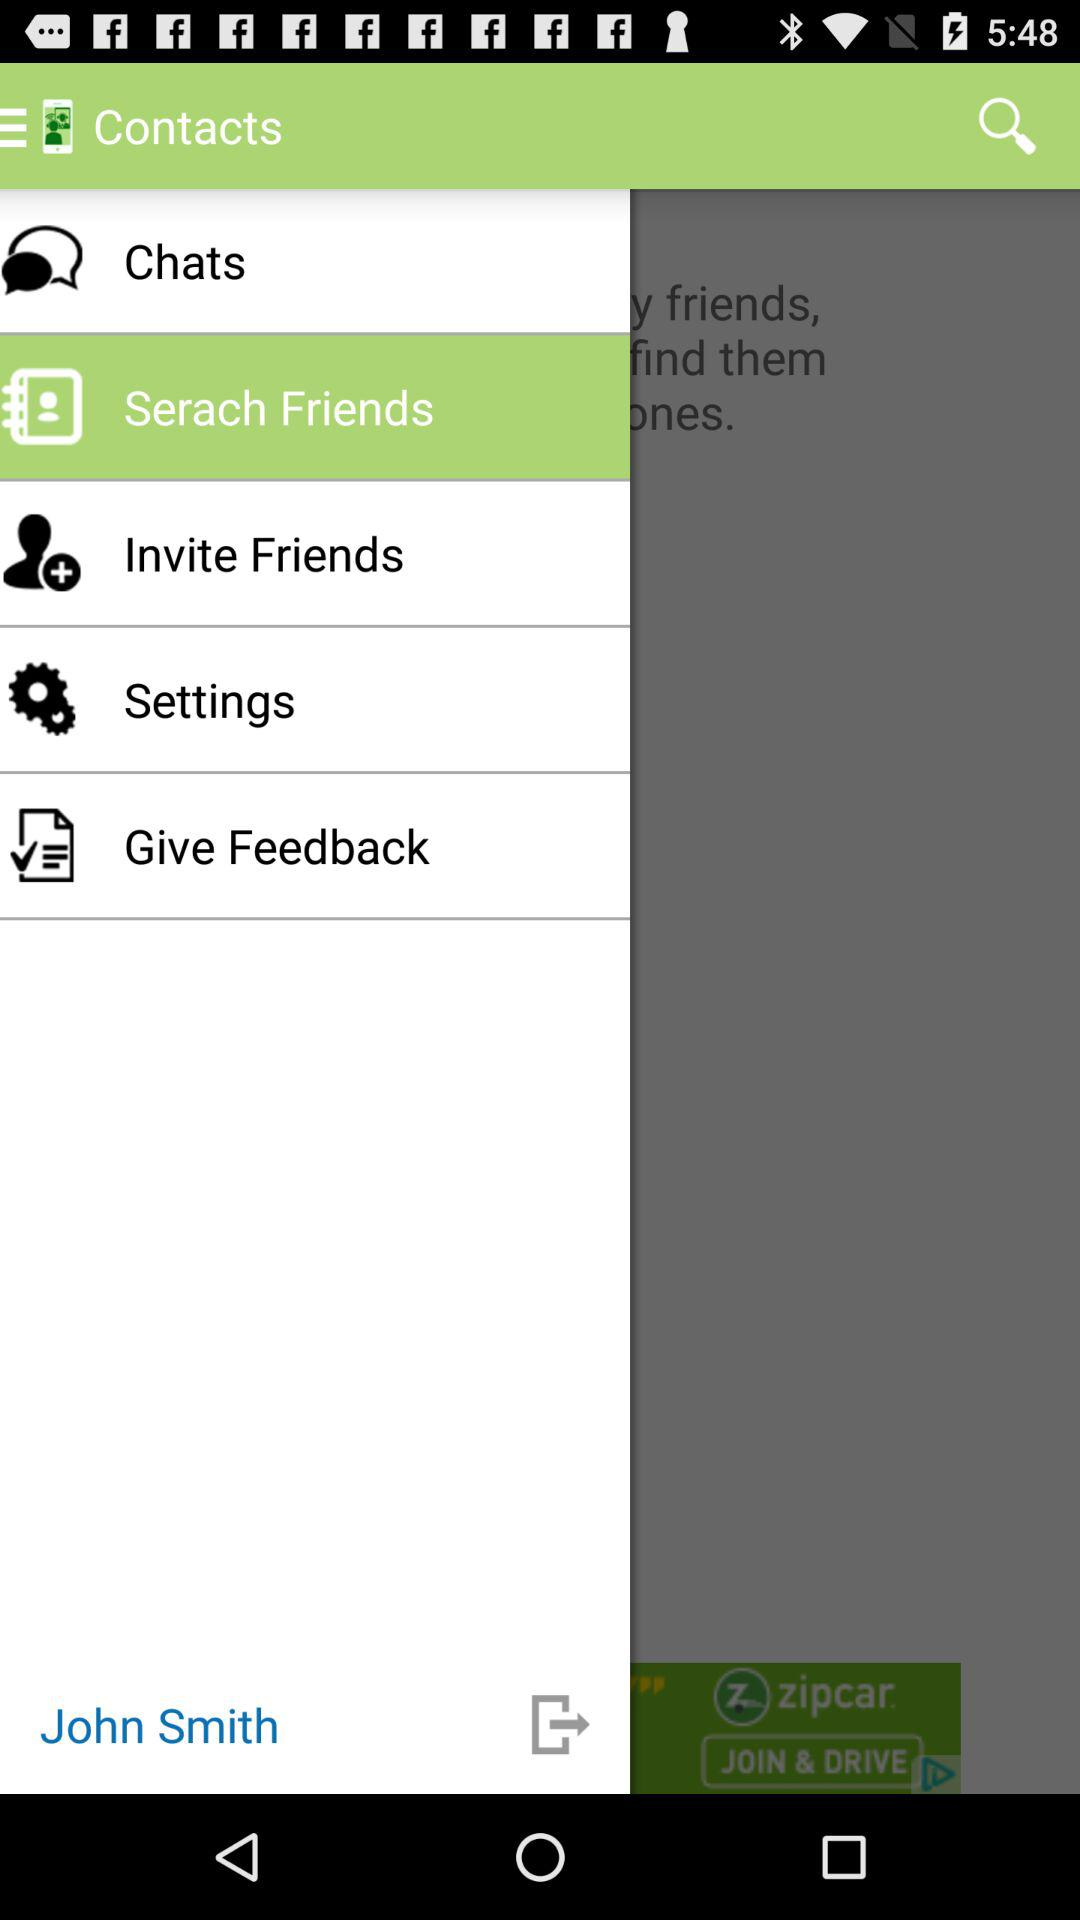What is the application name? The application name is "Contacts". 